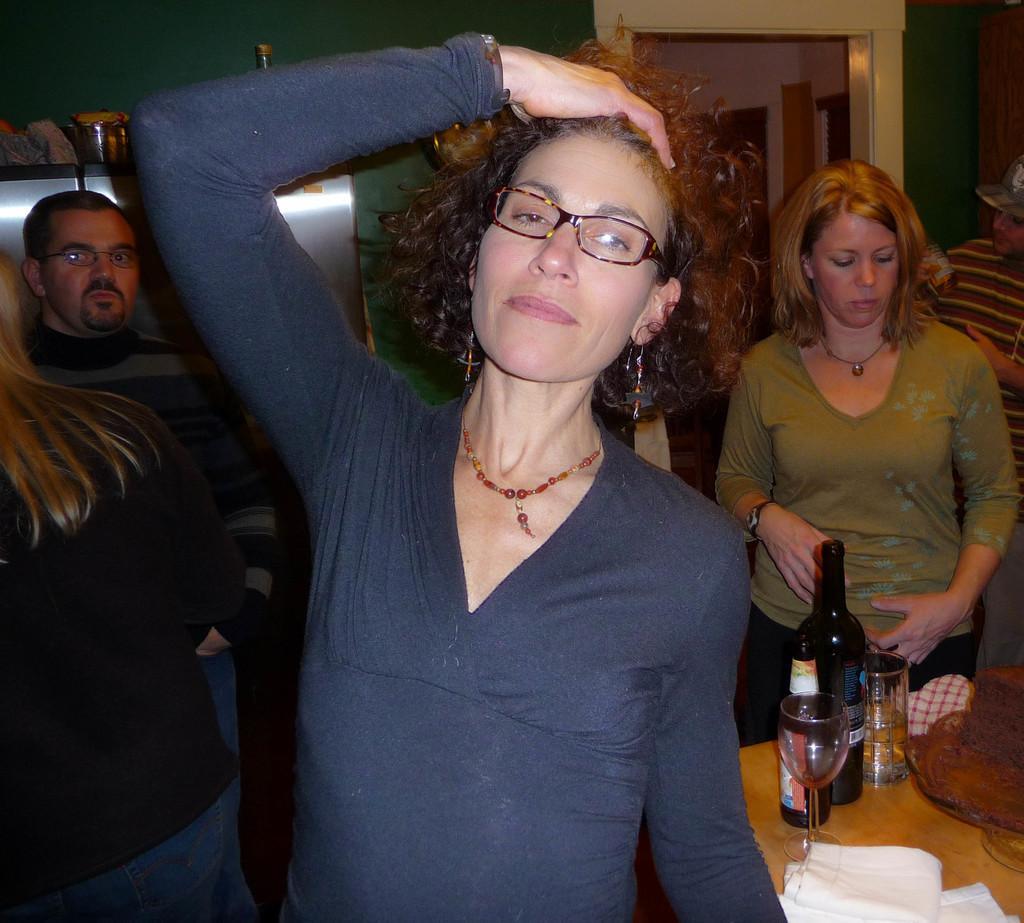Can you describe this image briefly? In this image i can see a woman standing. In the background i can see few other people standing, a table, few wines bottles and glasses on the table, and a wall. 